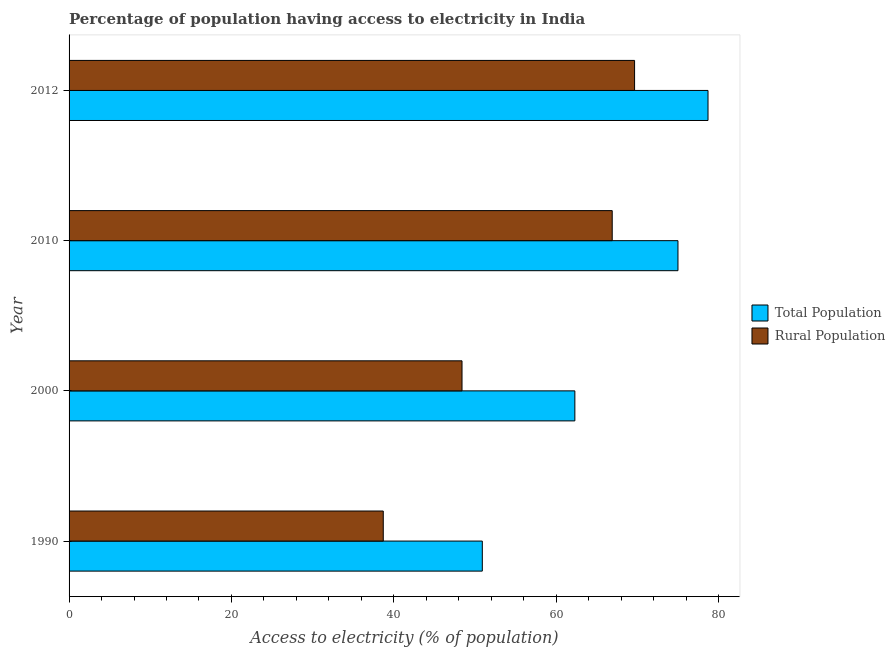How many different coloured bars are there?
Offer a very short reply. 2. How many groups of bars are there?
Keep it short and to the point. 4. Are the number of bars per tick equal to the number of legend labels?
Your answer should be compact. Yes. How many bars are there on the 2nd tick from the bottom?
Offer a very short reply. 2. What is the label of the 1st group of bars from the top?
Give a very brief answer. 2012. In how many cases, is the number of bars for a given year not equal to the number of legend labels?
Keep it short and to the point. 0. What is the percentage of rural population having access to electricity in 2012?
Give a very brief answer. 69.65. Across all years, what is the maximum percentage of population having access to electricity?
Keep it short and to the point. 78.7. Across all years, what is the minimum percentage of population having access to electricity?
Your answer should be very brief. 50.9. In which year was the percentage of population having access to electricity maximum?
Your response must be concise. 2012. What is the total percentage of rural population having access to electricity in the graph?
Make the answer very short. 223.65. What is the difference between the percentage of population having access to electricity in 2000 and that in 2012?
Provide a succinct answer. -16.4. What is the difference between the percentage of rural population having access to electricity in 2010 and the percentage of population having access to electricity in 1990?
Offer a terse response. 16. What is the average percentage of population having access to electricity per year?
Your answer should be compact. 66.72. In the year 2000, what is the difference between the percentage of population having access to electricity and percentage of rural population having access to electricity?
Your answer should be very brief. 13.9. In how many years, is the percentage of population having access to electricity greater than 48 %?
Give a very brief answer. 4. What is the ratio of the percentage of rural population having access to electricity in 1990 to that in 2012?
Give a very brief answer. 0.56. What is the difference between the highest and the second highest percentage of rural population having access to electricity?
Your answer should be very brief. 2.75. What is the difference between the highest and the lowest percentage of population having access to electricity?
Your response must be concise. 27.8. Is the sum of the percentage of rural population having access to electricity in 2000 and 2012 greater than the maximum percentage of population having access to electricity across all years?
Provide a succinct answer. Yes. What does the 1st bar from the top in 2000 represents?
Your answer should be compact. Rural Population. What does the 1st bar from the bottom in 2010 represents?
Provide a succinct answer. Total Population. How many bars are there?
Provide a succinct answer. 8. Does the graph contain any zero values?
Make the answer very short. No. Does the graph contain grids?
Your answer should be very brief. No. Where does the legend appear in the graph?
Give a very brief answer. Center right. How many legend labels are there?
Your response must be concise. 2. What is the title of the graph?
Ensure brevity in your answer.  Percentage of population having access to electricity in India. What is the label or title of the X-axis?
Give a very brief answer. Access to electricity (% of population). What is the label or title of the Y-axis?
Provide a short and direct response. Year. What is the Access to electricity (% of population) of Total Population in 1990?
Keep it short and to the point. 50.9. What is the Access to electricity (% of population) in Rural Population in 1990?
Provide a succinct answer. 38.7. What is the Access to electricity (% of population) in Total Population in 2000?
Your answer should be very brief. 62.3. What is the Access to electricity (% of population) in Rural Population in 2000?
Provide a short and direct response. 48.4. What is the Access to electricity (% of population) in Rural Population in 2010?
Provide a short and direct response. 66.9. What is the Access to electricity (% of population) of Total Population in 2012?
Your response must be concise. 78.7. What is the Access to electricity (% of population) of Rural Population in 2012?
Keep it short and to the point. 69.65. Across all years, what is the maximum Access to electricity (% of population) of Total Population?
Make the answer very short. 78.7. Across all years, what is the maximum Access to electricity (% of population) of Rural Population?
Provide a short and direct response. 69.65. Across all years, what is the minimum Access to electricity (% of population) in Total Population?
Offer a terse response. 50.9. Across all years, what is the minimum Access to electricity (% of population) of Rural Population?
Offer a terse response. 38.7. What is the total Access to electricity (% of population) in Total Population in the graph?
Provide a succinct answer. 266.9. What is the total Access to electricity (% of population) in Rural Population in the graph?
Offer a very short reply. 223.65. What is the difference between the Access to electricity (% of population) in Rural Population in 1990 and that in 2000?
Provide a succinct answer. -9.7. What is the difference between the Access to electricity (% of population) in Total Population in 1990 and that in 2010?
Offer a terse response. -24.1. What is the difference between the Access to electricity (% of population) in Rural Population in 1990 and that in 2010?
Your response must be concise. -28.2. What is the difference between the Access to electricity (% of population) in Total Population in 1990 and that in 2012?
Keep it short and to the point. -27.8. What is the difference between the Access to electricity (% of population) in Rural Population in 1990 and that in 2012?
Your response must be concise. -30.95. What is the difference between the Access to electricity (% of population) of Total Population in 2000 and that in 2010?
Provide a succinct answer. -12.7. What is the difference between the Access to electricity (% of population) in Rural Population in 2000 and that in 2010?
Your answer should be compact. -18.5. What is the difference between the Access to electricity (% of population) in Total Population in 2000 and that in 2012?
Offer a terse response. -16.4. What is the difference between the Access to electricity (% of population) in Rural Population in 2000 and that in 2012?
Offer a very short reply. -21.25. What is the difference between the Access to electricity (% of population) of Total Population in 2010 and that in 2012?
Provide a short and direct response. -3.7. What is the difference between the Access to electricity (% of population) of Rural Population in 2010 and that in 2012?
Offer a very short reply. -2.75. What is the difference between the Access to electricity (% of population) in Total Population in 1990 and the Access to electricity (% of population) in Rural Population in 2000?
Your answer should be very brief. 2.5. What is the difference between the Access to electricity (% of population) of Total Population in 1990 and the Access to electricity (% of population) of Rural Population in 2012?
Give a very brief answer. -18.75. What is the difference between the Access to electricity (% of population) of Total Population in 2000 and the Access to electricity (% of population) of Rural Population in 2010?
Your answer should be very brief. -4.6. What is the difference between the Access to electricity (% of population) in Total Population in 2000 and the Access to electricity (% of population) in Rural Population in 2012?
Offer a very short reply. -7.35. What is the difference between the Access to electricity (% of population) in Total Population in 2010 and the Access to electricity (% of population) in Rural Population in 2012?
Offer a very short reply. 5.35. What is the average Access to electricity (% of population) in Total Population per year?
Provide a succinct answer. 66.72. What is the average Access to electricity (% of population) in Rural Population per year?
Your response must be concise. 55.91. In the year 2000, what is the difference between the Access to electricity (% of population) in Total Population and Access to electricity (% of population) in Rural Population?
Offer a very short reply. 13.9. In the year 2012, what is the difference between the Access to electricity (% of population) in Total Population and Access to electricity (% of population) in Rural Population?
Make the answer very short. 9.05. What is the ratio of the Access to electricity (% of population) in Total Population in 1990 to that in 2000?
Your answer should be compact. 0.82. What is the ratio of the Access to electricity (% of population) in Rural Population in 1990 to that in 2000?
Give a very brief answer. 0.8. What is the ratio of the Access to electricity (% of population) of Total Population in 1990 to that in 2010?
Make the answer very short. 0.68. What is the ratio of the Access to electricity (% of population) in Rural Population in 1990 to that in 2010?
Give a very brief answer. 0.58. What is the ratio of the Access to electricity (% of population) in Total Population in 1990 to that in 2012?
Give a very brief answer. 0.65. What is the ratio of the Access to electricity (% of population) in Rural Population in 1990 to that in 2012?
Make the answer very short. 0.56. What is the ratio of the Access to electricity (% of population) of Total Population in 2000 to that in 2010?
Your response must be concise. 0.83. What is the ratio of the Access to electricity (% of population) in Rural Population in 2000 to that in 2010?
Give a very brief answer. 0.72. What is the ratio of the Access to electricity (% of population) in Total Population in 2000 to that in 2012?
Give a very brief answer. 0.79. What is the ratio of the Access to electricity (% of population) in Rural Population in 2000 to that in 2012?
Provide a succinct answer. 0.69. What is the ratio of the Access to electricity (% of population) in Total Population in 2010 to that in 2012?
Offer a terse response. 0.95. What is the ratio of the Access to electricity (% of population) of Rural Population in 2010 to that in 2012?
Keep it short and to the point. 0.96. What is the difference between the highest and the second highest Access to electricity (% of population) in Rural Population?
Your answer should be compact. 2.75. What is the difference between the highest and the lowest Access to electricity (% of population) of Total Population?
Provide a short and direct response. 27.8. What is the difference between the highest and the lowest Access to electricity (% of population) in Rural Population?
Offer a terse response. 30.95. 